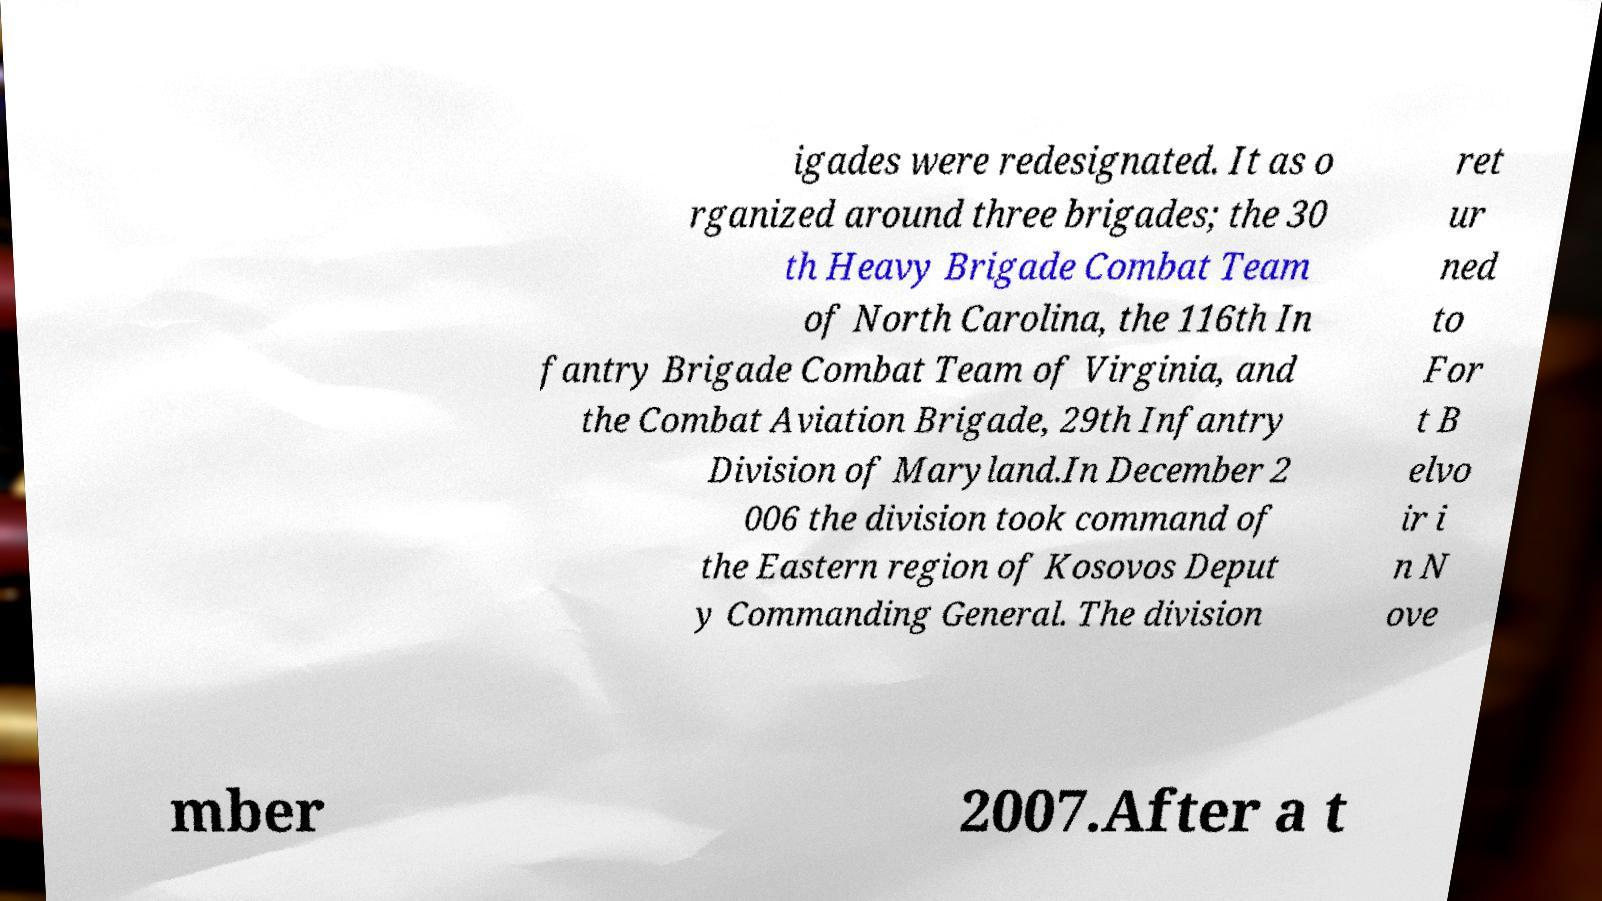What messages or text are displayed in this image? I need them in a readable, typed format. igades were redesignated. It as o rganized around three brigades; the 30 th Heavy Brigade Combat Team of North Carolina, the 116th In fantry Brigade Combat Team of Virginia, and the Combat Aviation Brigade, 29th Infantry Division of Maryland.In December 2 006 the division took command of the Eastern region of Kosovos Deput y Commanding General. The division ret ur ned to For t B elvo ir i n N ove mber 2007.After a t 